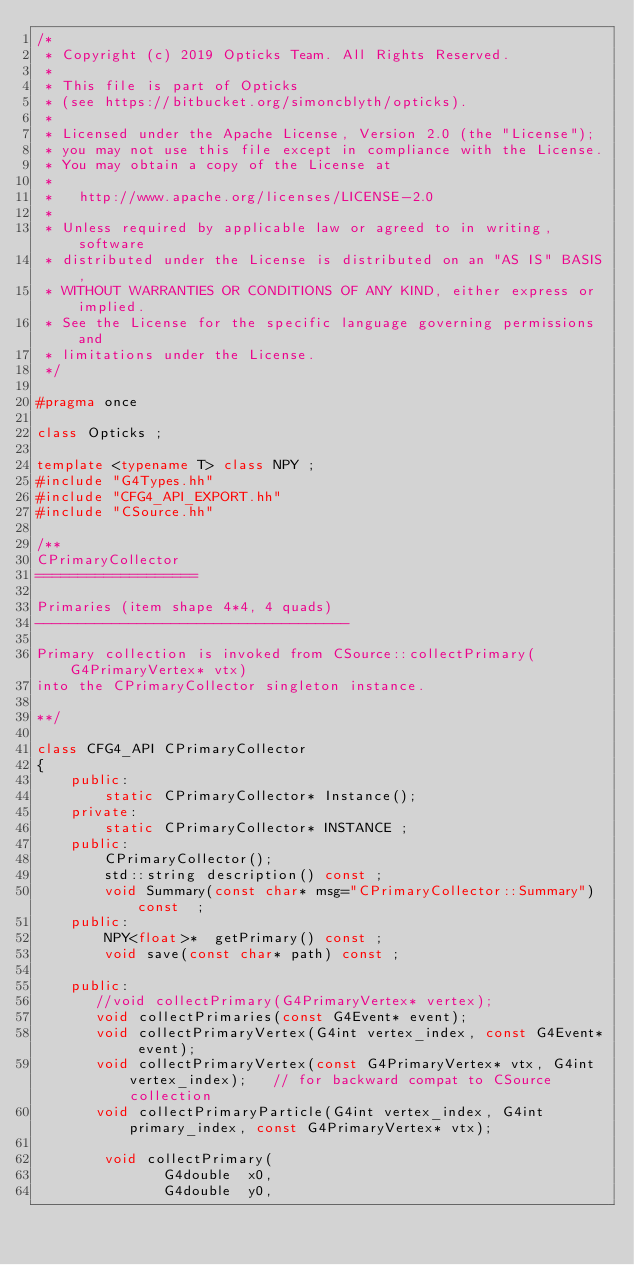Convert code to text. <code><loc_0><loc_0><loc_500><loc_500><_C++_>/*
 * Copyright (c) 2019 Opticks Team. All Rights Reserved.
 *
 * This file is part of Opticks
 * (see https://bitbucket.org/simoncblyth/opticks).
 *
 * Licensed under the Apache License, Version 2.0 (the "License"); 
 * you may not use this file except in compliance with the License.  
 * You may obtain a copy of the License at
 *
 *   http://www.apache.org/licenses/LICENSE-2.0
 *
 * Unless required by applicable law or agreed to in writing, software 
 * distributed under the License is distributed on an "AS IS" BASIS, 
 * WITHOUT WARRANTIES OR CONDITIONS OF ANY KIND, either express or implied.  
 * See the License for the specific language governing permissions and 
 * limitations under the License.
 */

#pragma once

class Opticks ; 

template <typename T> class NPY ;
#include "G4Types.hh"
#include "CFG4_API_EXPORT.hh"
#include "CSource.hh"

/**
CPrimaryCollector
===================

Primaries (item shape 4*4, 4 quads)
-------------------------------------

Primary collection is invoked from CSource::collectPrimary(G4PrimaryVertex* vtx)
into the CPrimaryCollector singleton instance.

**/

class CFG4_API CPrimaryCollector 
{
    public:
        static CPrimaryCollector* Instance();
    private:
        static CPrimaryCollector* INSTANCE ;      
    public:
        CPrimaryCollector();  
        std::string description() const ;
        void Summary(const char* msg="CPrimaryCollector::Summary") const  ;
    public:
        NPY<float>*  getPrimary() const ;
        void save(const char* path) const ; 

    public:
       //void collectPrimary(G4PrimaryVertex* vertex);
       void collectPrimaries(const G4Event* event);
       void collectPrimaryVertex(G4int vertex_index, const G4Event* event);
       void collectPrimaryVertex(const G4PrimaryVertex* vtx, G4int vertex_index);   // for backward compat to CSource collection
       void collectPrimaryParticle(G4int vertex_index, G4int primary_index, const G4PrimaryVertex* vtx);

        void collectPrimary(
               G4double  x0,
               G4double  y0,</code> 